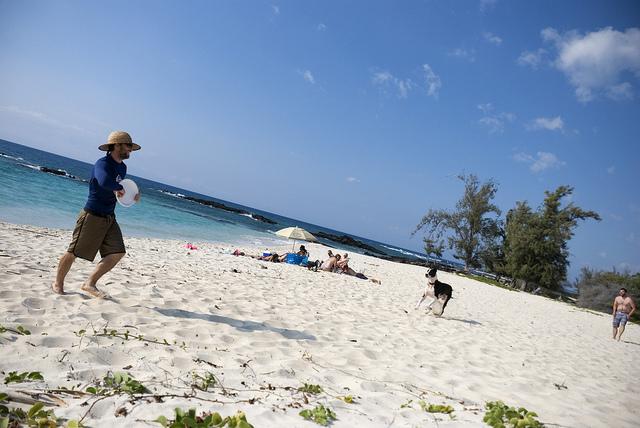Who is the "monkey" in the middle?
Quick response, please. Dog. Where is the man playing with his dog?
Keep it brief. Beach. Is the water green?
Write a very short answer. No. 